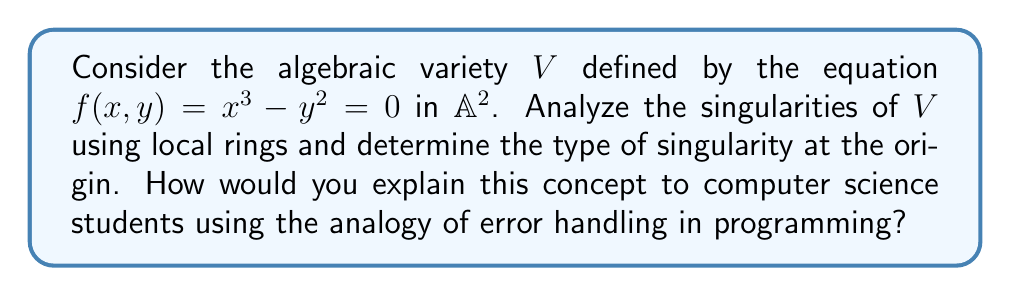Can you answer this question? 1. First, let's compute the partial derivatives of $f(x,y)$:
   $$\frac{\partial f}{\partial x} = 3x^2$$
   $$\frac{\partial f}{\partial y} = -2y$$

2. The singular points of $V$ are where both partial derivatives vanish simultaneously with $f(x,y) = 0$. Solving this system:
   $$x^3 - y^2 = 0$$
   $$3x^2 = 0$$
   $$-2y = 0$$

3. We find that the only singular point is the origin $(0,0)$.

4. To analyze the singularity at $(0,0)$, we consider the local ring $\mathcal{O}_{V,(0,0)}$. This is analogous to examining the behavior of a function near a critical point in programming.

5. The maximal ideal $\mathfrak{m}$ of $\mathcal{O}_{V,(0,0)}$ is generated by $x$ and $y$. We can express $f(x,y)$ in terms of these generators:
   $$f(x,y) = x^3 - y^2 = x \cdot x^2 - y \cdot y$$

6. The tangent cone at $(0,0)$ is given by the lowest degree terms of $f$ when expressed in $\mathfrak{m}$, which is $-y^2$.

7. Since the tangent cone is not a product of distinct linear factors, the singularity at $(0,0)$ is called a cusp.

8. In programming terms, this is similar to error handling where different types of errors (like runtime errors vs. compile-time errors) are treated differently. The cusp singularity represents a "special case" that requires unique handling, much like how certain errors in programming might require specific exception handling.

9. The multiplicity of the singularity is 2, as the lowest degree term in the expansion of $f$ at $(0,0)$ is of degree 2. This is analogous to the severity or priority of an error in programming.
Answer: The origin $(0,0)$ is a cusp singularity with multiplicity 2. 